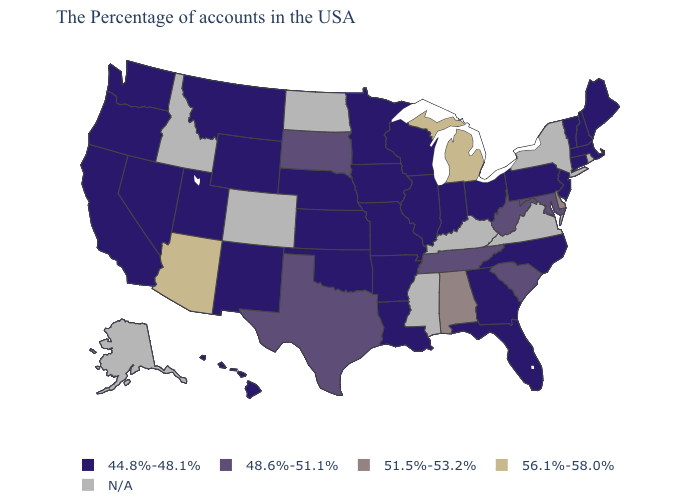What is the value of Arkansas?
Short answer required. 44.8%-48.1%. What is the value of Washington?
Quick response, please. 44.8%-48.1%. Does Michigan have the highest value in the USA?
Answer briefly. Yes. What is the highest value in the MidWest ?
Short answer required. 56.1%-58.0%. Does the map have missing data?
Write a very short answer. Yes. Among the states that border Indiana , which have the highest value?
Short answer required. Michigan. Among the states that border Delaware , does Maryland have the highest value?
Be succinct. Yes. Name the states that have a value in the range 44.8%-48.1%?
Answer briefly. Maine, Massachusetts, New Hampshire, Vermont, Connecticut, New Jersey, Pennsylvania, North Carolina, Ohio, Florida, Georgia, Indiana, Wisconsin, Illinois, Louisiana, Missouri, Arkansas, Minnesota, Iowa, Kansas, Nebraska, Oklahoma, Wyoming, New Mexico, Utah, Montana, Nevada, California, Washington, Oregon, Hawaii. Name the states that have a value in the range N/A?
Be succinct. Rhode Island, New York, Virginia, Kentucky, Mississippi, North Dakota, Colorado, Idaho, Alaska. Name the states that have a value in the range 48.6%-51.1%?
Give a very brief answer. Maryland, South Carolina, West Virginia, Tennessee, Texas, South Dakota. Name the states that have a value in the range 48.6%-51.1%?
Concise answer only. Maryland, South Carolina, West Virginia, Tennessee, Texas, South Dakota. Among the states that border New Mexico , which have the lowest value?
Keep it brief. Oklahoma, Utah. Name the states that have a value in the range N/A?
Short answer required. Rhode Island, New York, Virginia, Kentucky, Mississippi, North Dakota, Colorado, Idaho, Alaska. Name the states that have a value in the range 48.6%-51.1%?
Answer briefly. Maryland, South Carolina, West Virginia, Tennessee, Texas, South Dakota. 